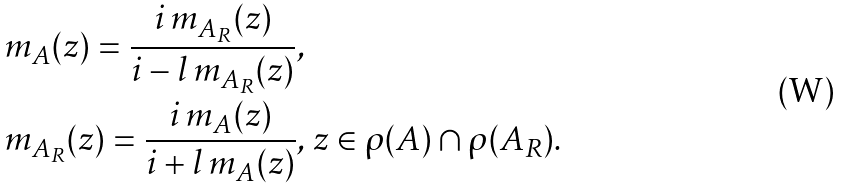<formula> <loc_0><loc_0><loc_500><loc_500>& m _ { A } ( z ) = \frac { i \, m _ { A _ { R } } ( z ) } { i - l \, m _ { A _ { R } } ( z ) } , \\ & m _ { A _ { R } } ( z ) = \frac { i \, m _ { A } ( z ) } { i + l \, m _ { A } ( z ) } , \, z \in \rho ( A ) \cap \rho ( A _ { R } ) .</formula> 